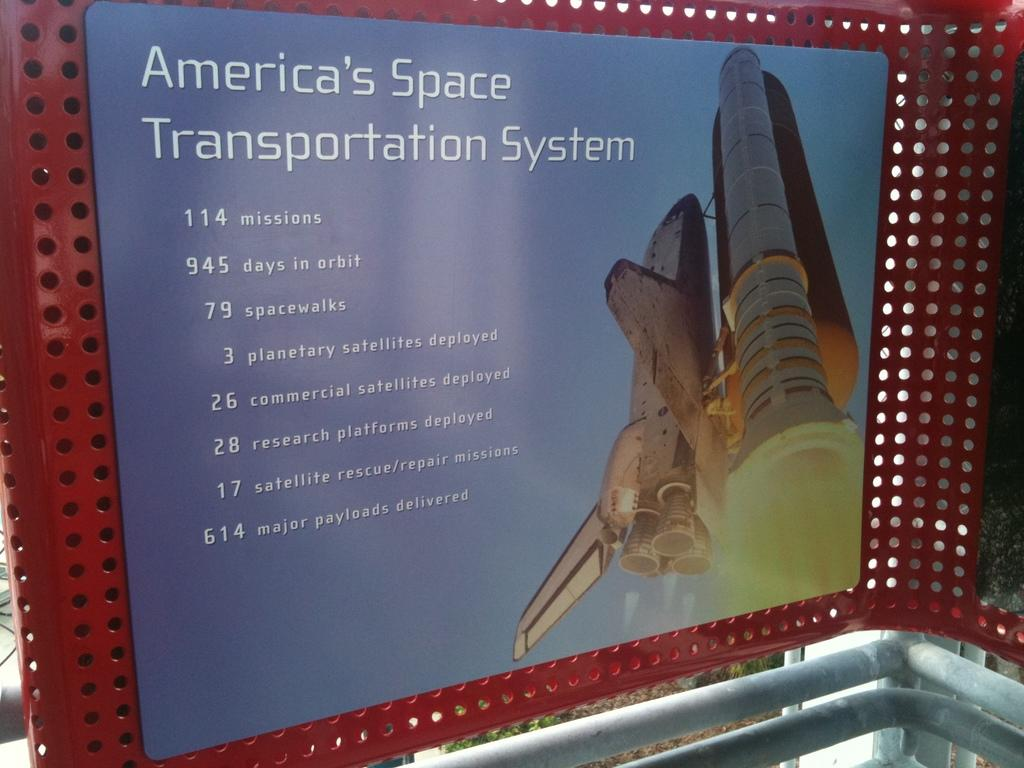What is the main object in the image? There is a display board in the image. What is on the display board? The display board contains text and pictures. How is the display board supported or attached? The display board is attached to a metal rod fence. What can be seen beneath the metal rod fence? The metal rod fence has metal rods beneath it. What type of crayon is being used to draw on the plant in the image? There is no crayon or plant present in the image. What year is depicted in the image? The provided facts do not mention any specific year or time period in the image. 